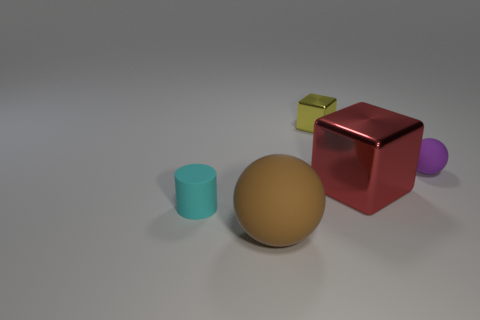How many shiny things are gray objects or red objects?
Your answer should be compact. 1. How many cylinders are in front of the rubber sphere in front of the big red object?
Provide a succinct answer. 0. There is a object that is on the right side of the tiny metal block and in front of the tiny purple rubber thing; what is its shape?
Make the answer very short. Cube. The thing behind the matte thing that is behind the small matte object that is on the left side of the large rubber ball is made of what material?
Keep it short and to the point. Metal. What material is the small purple thing?
Give a very brief answer. Rubber. Are the cyan cylinder and the sphere on the right side of the big red object made of the same material?
Offer a very short reply. Yes. What color is the small matte object left of the small yellow object behind the brown object?
Make the answer very short. Cyan. How big is the thing that is behind the big metal object and on the left side of the red object?
Offer a terse response. Small. How many other objects are the same shape as the small metallic thing?
Your answer should be compact. 1. Does the yellow thing have the same shape as the small object that is on the right side of the tiny metal block?
Give a very brief answer. No. 